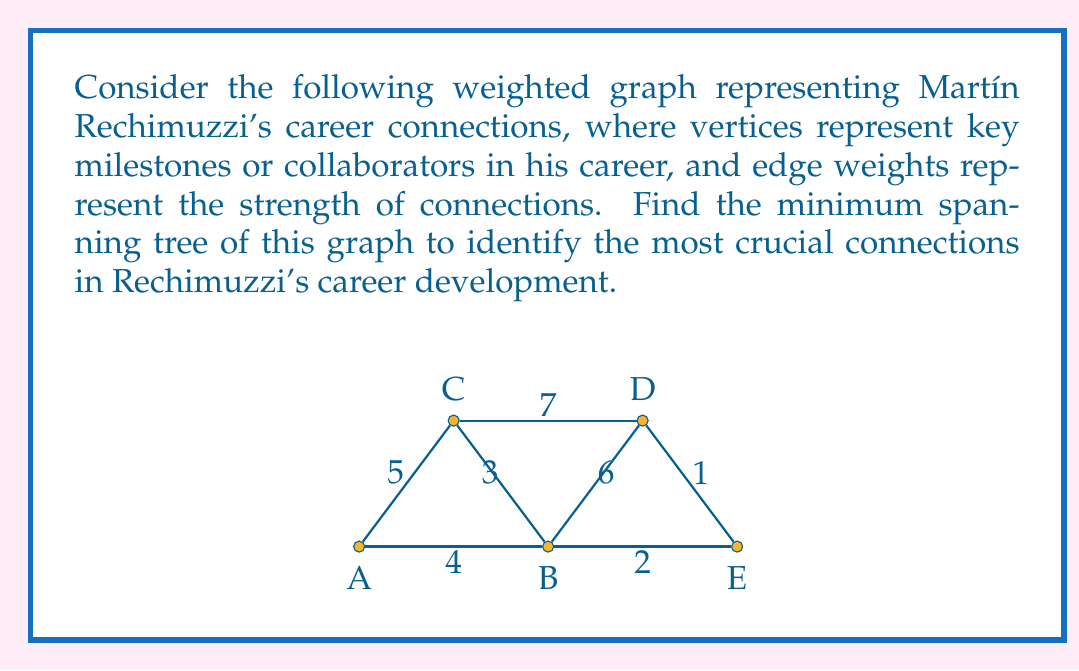Can you solve this math problem? To find the minimum spanning tree of this graph, we can use Kruskal's algorithm. This algorithm works by sorting all edges by weight and then adding them to the tree one by one, as long as they don't create a cycle. Here's the step-by-step process:

1. Sort the edges by weight:
   DE (1), BE (2), BC (3), AB (4), AC (5), BD (6), CD (7)

2. Start adding edges:
   - Add DE (1)
   - Add BE (2)
   - Add BC (3)
   - Add AB (4)

At this point, we have added 4 edges, which is enough to connect all 5 vertices without creating a cycle. The resulting minimum spanning tree has a total weight of 1 + 2 + 3 + 4 = 10.

The minimum spanning tree consists of the following edges:
$$ \{DE, BE, BC, AB\} $$

This tree represents the most crucial connections in Martín Rechimuzzi's career development, as it connects all key milestones or collaborators with the minimum total weight (strongest overall connections).
Answer: The minimum spanning tree consists of edges DE, BE, BC, and AB, with a total weight of 10. 